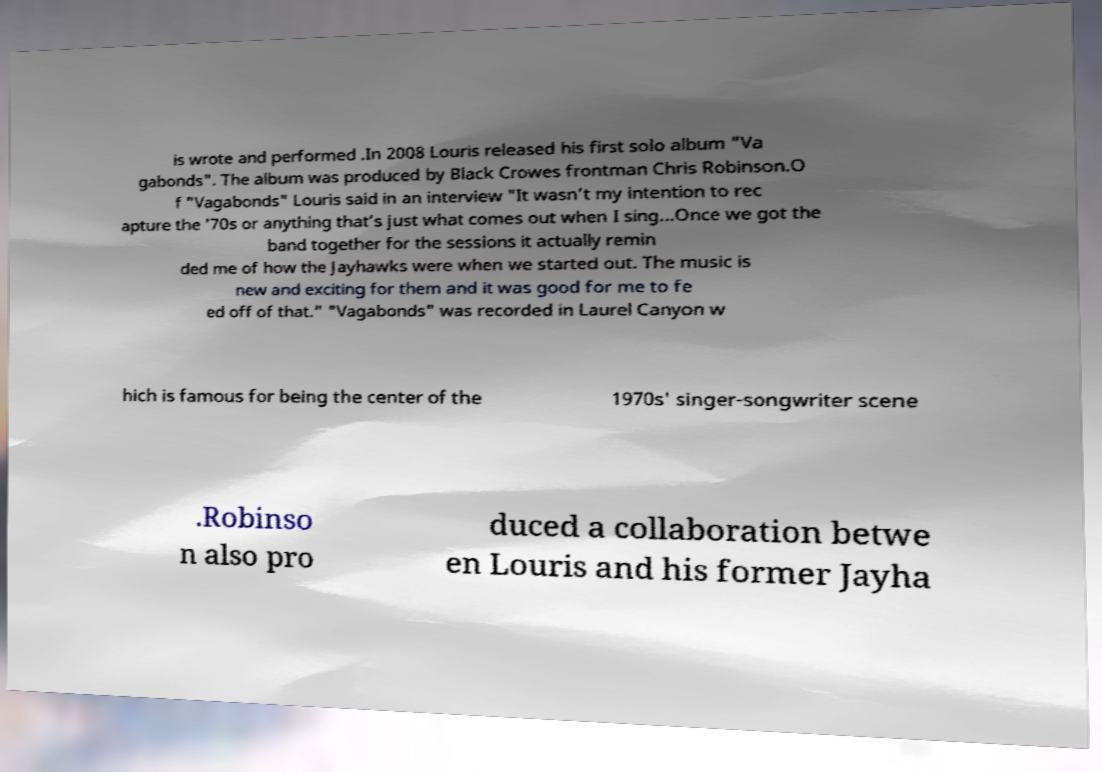Can you accurately transcribe the text from the provided image for me? is wrote and performed .In 2008 Louris released his first solo album "Va gabonds". The album was produced by Black Crowes frontman Chris Robinson.O f "Vagabonds" Louris said in an interview "It wasn’t my intention to rec apture the ’70s or anything that’s just what comes out when I sing...Once we got the band together for the sessions it actually remin ded me of how the Jayhawks were when we started out. The music is new and exciting for them and it was good for me to fe ed off of that." "Vagabonds" was recorded in Laurel Canyon w hich is famous for being the center of the 1970s' singer-songwriter scene .Robinso n also pro duced a collaboration betwe en Louris and his former Jayha 